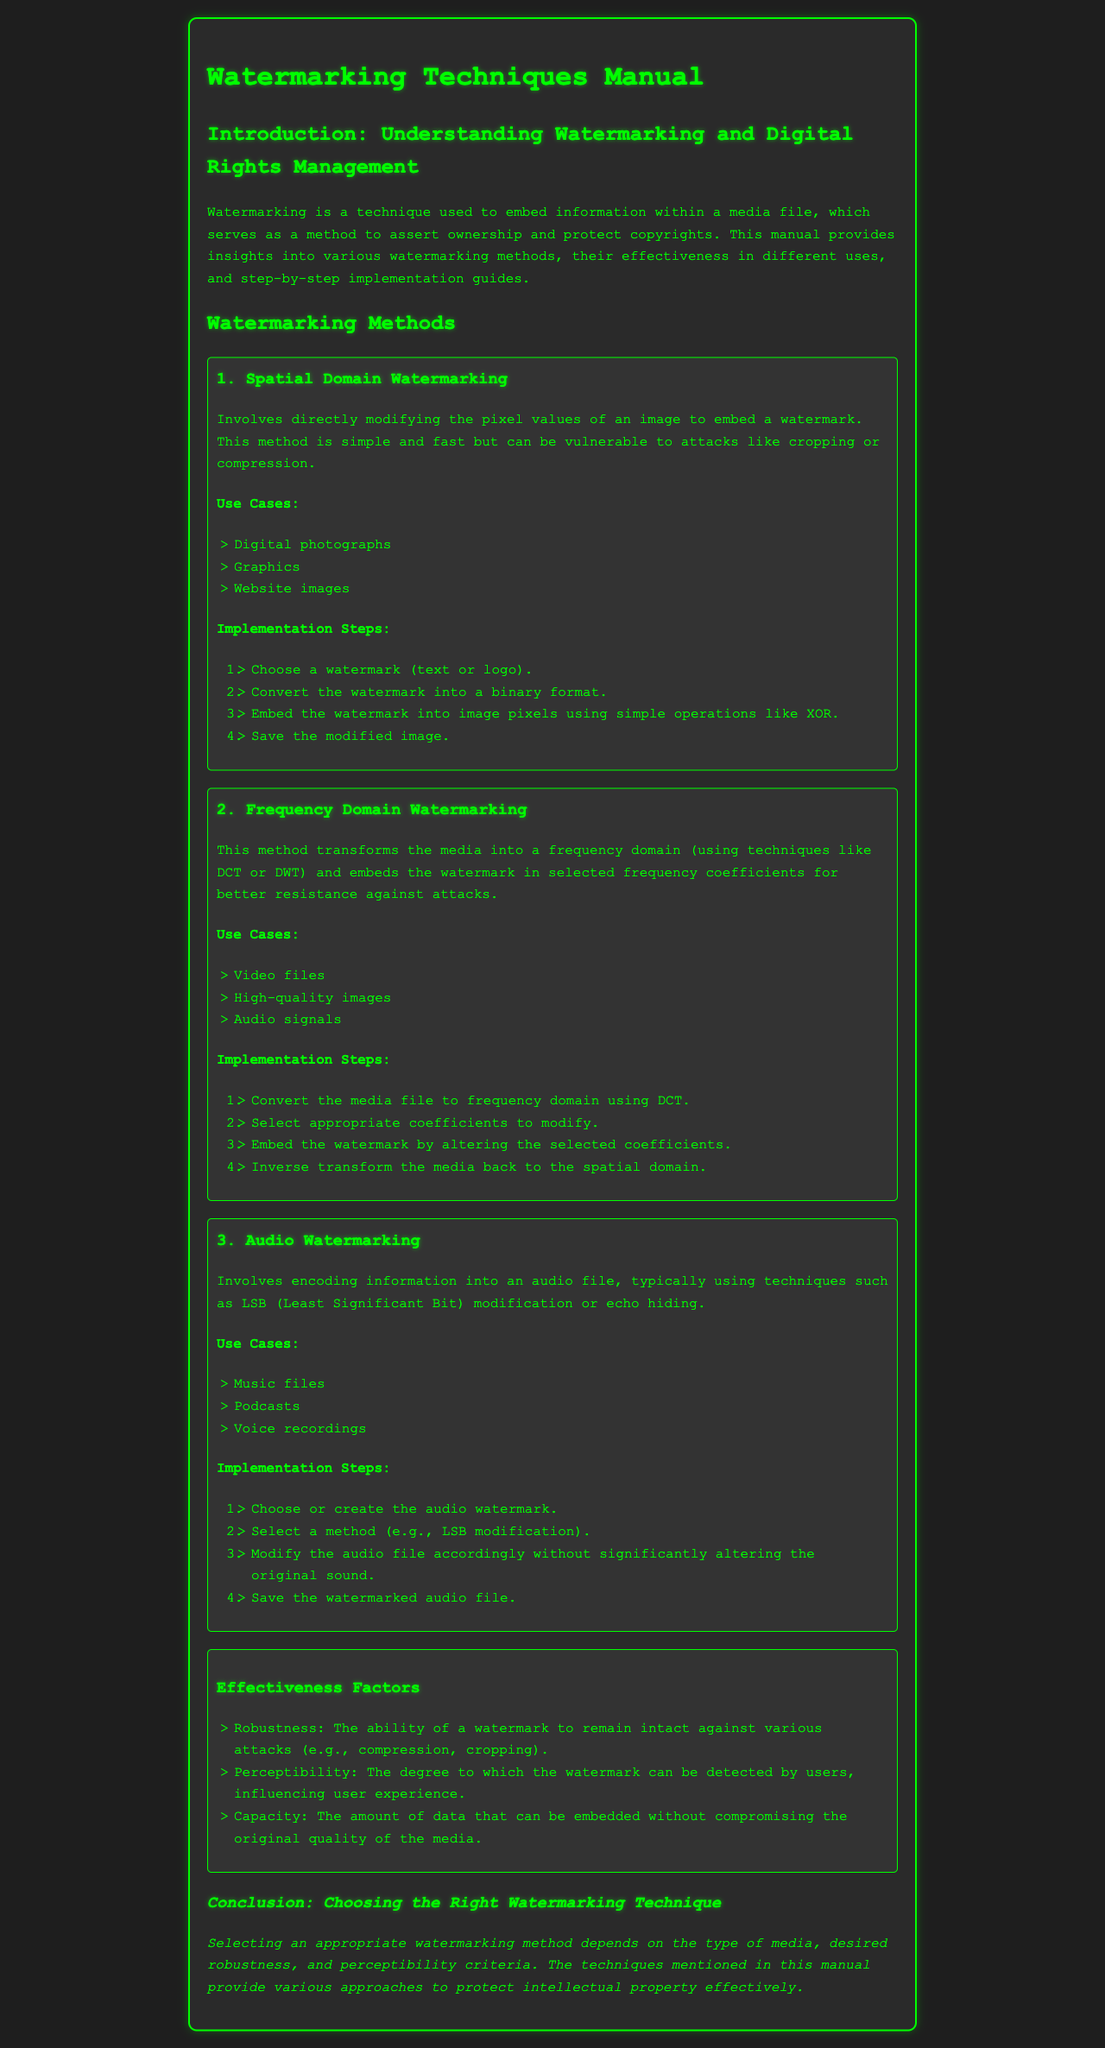What is the first watermarking method discussed? The first watermarking method is listed as Spatial Domain Watermarking.
Answer: Spatial Domain Watermarking What are the use cases for frequency domain watermarking? The use cases include video files, high-quality images, and audio signals.
Answer: Video files, high-quality images, audio signals What is the primary technique used in audio watermarking? The primary technique mentioned for audio watermarking includes LSB modification or echo hiding.
Answer: LSB modification How many steps are outlined for implementing spatial domain watermarking? There are four implementation steps outlined for spatial domain watermarking.
Answer: Four What is the goal of watermarking as stated in the introduction? The goal of watermarking is to assert ownership and protect copyrights.
Answer: Assert ownership and protect copyrights What effectiveness factor relates to user experience? The effectiveness factor that relates to user experience is perceptibility.
Answer: Perceptibility Which watermarking method is described as simple and fast but vulnerable to attacks? The watermarking method described as simple and fast but vulnerable to attacks is Spatial Domain Watermarking.
Answer: Spatial Domain Watermarking What is the last section titled in the manual? The last section of the manual is titled Conclusion: Choosing the Right Watermarking Technique.
Answer: Conclusion: Choosing the Right Watermarking Technique 